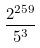Convert formula to latex. <formula><loc_0><loc_0><loc_500><loc_500>\frac { 2 ^ { 2 5 9 } } { 5 ^ { 3 } }</formula> 